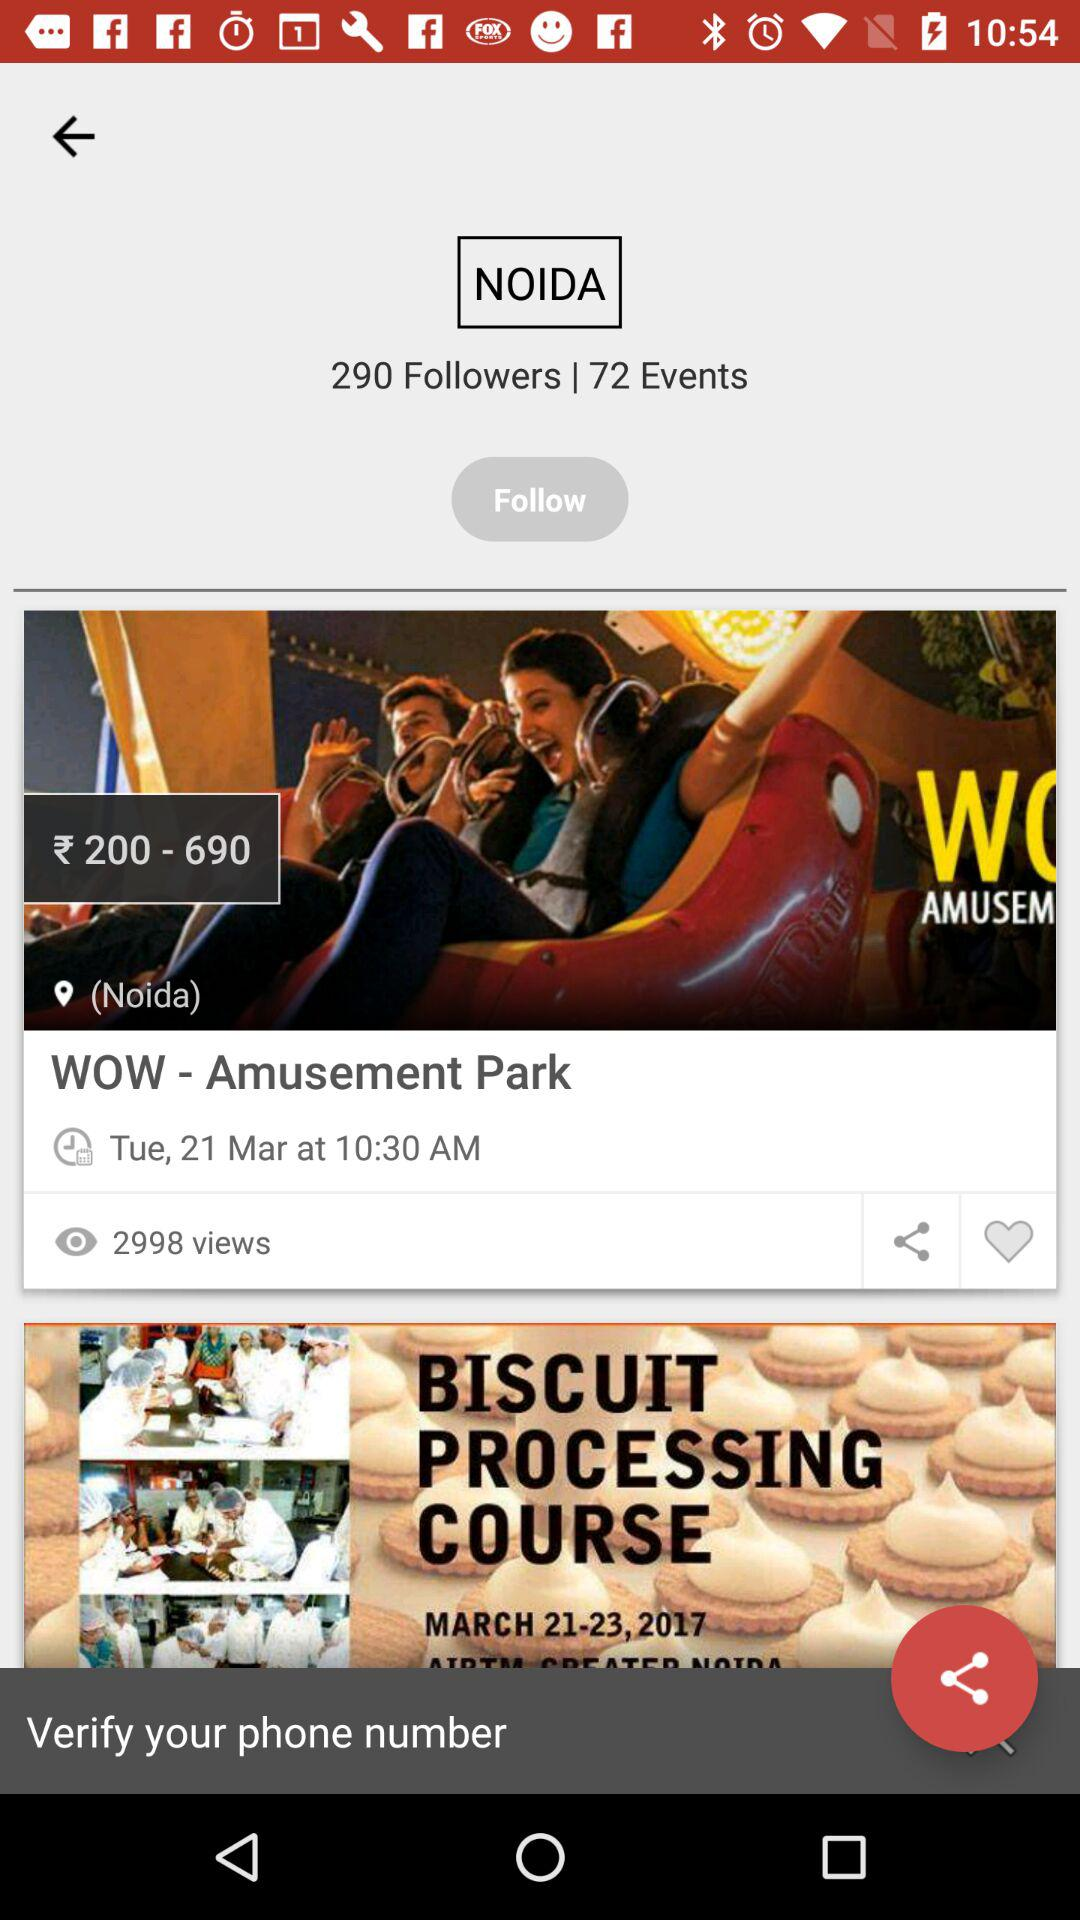What is the location? The location is Noida. 